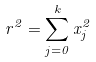Convert formula to latex. <formula><loc_0><loc_0><loc_500><loc_500>r ^ { 2 } = \sum _ { j = 0 } ^ { k } x _ { j } ^ { 2 }</formula> 